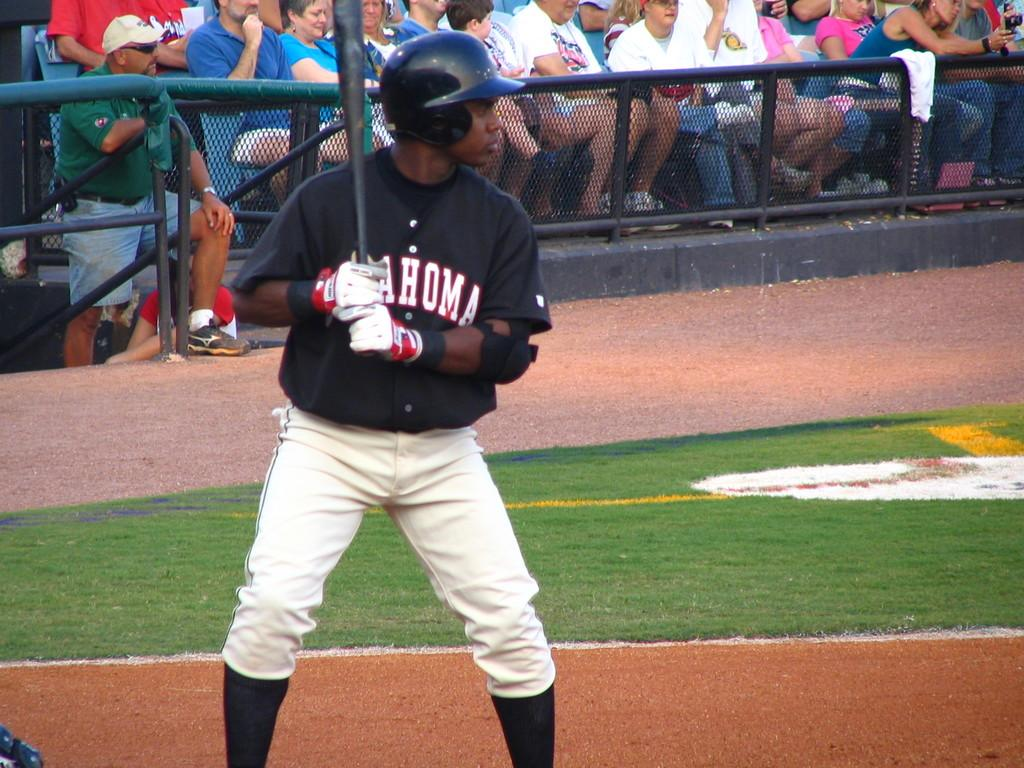<image>
Offer a succinct explanation of the picture presented. A baseball player with a jersey that says Oklahoma is getting ready to hit the ball in front of the crowd. 